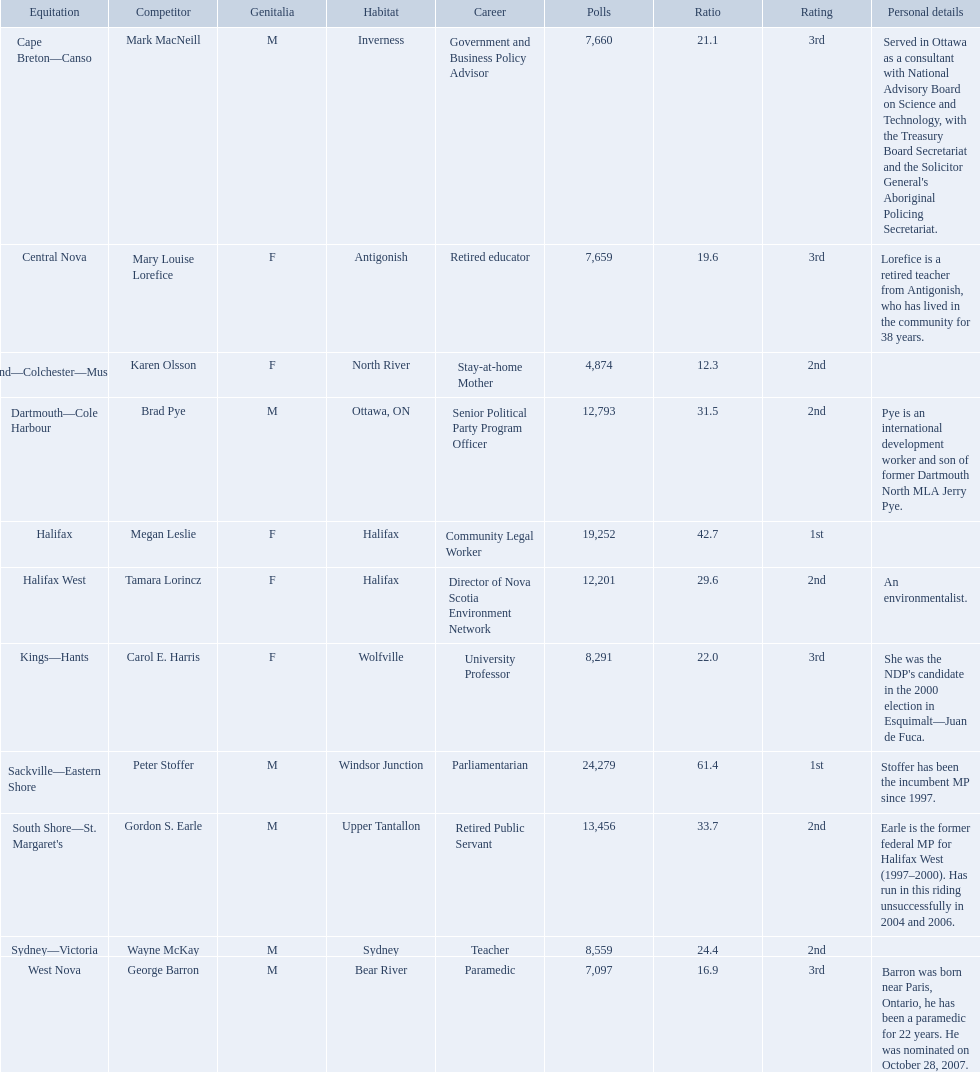Who were the new democratic party candidates, 2008? Mark MacNeill, Mary Louise Lorefice, Karen Olsson, Brad Pye, Megan Leslie, Tamara Lorincz, Carol E. Harris, Peter Stoffer, Gordon S. Earle, Wayne McKay, George Barron. Who had the 2nd highest number of votes? Megan Leslie, Peter Stoffer. How many votes did she receive? 19,252. 